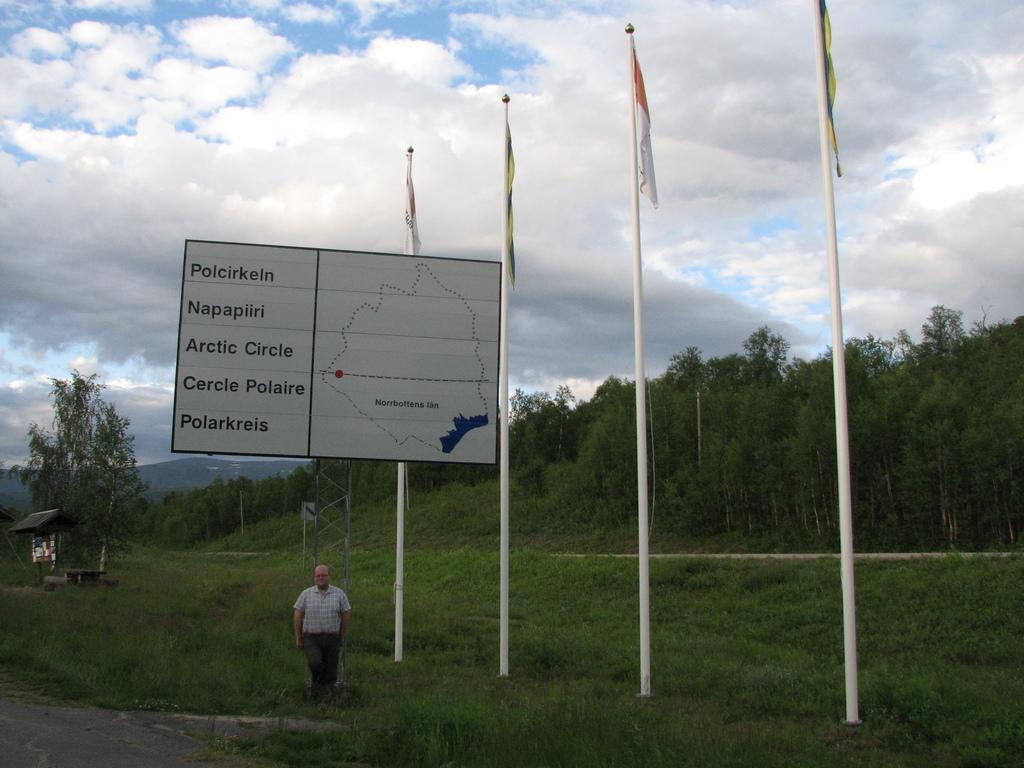Can you describe this image briefly? In this picture I can observe a board. In the middle of the picture I can observe four flags tied to the poles in this picture. There is some grass on the ground. In the background there are trees and some clouds in the sky. 